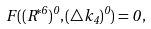Convert formula to latex. <formula><loc_0><loc_0><loc_500><loc_500>F ( ( R ^ { * 6 } ) ^ { 0 } , ( \triangle k _ { 4 } ) ^ { 0 } ) = 0 \, ,</formula> 